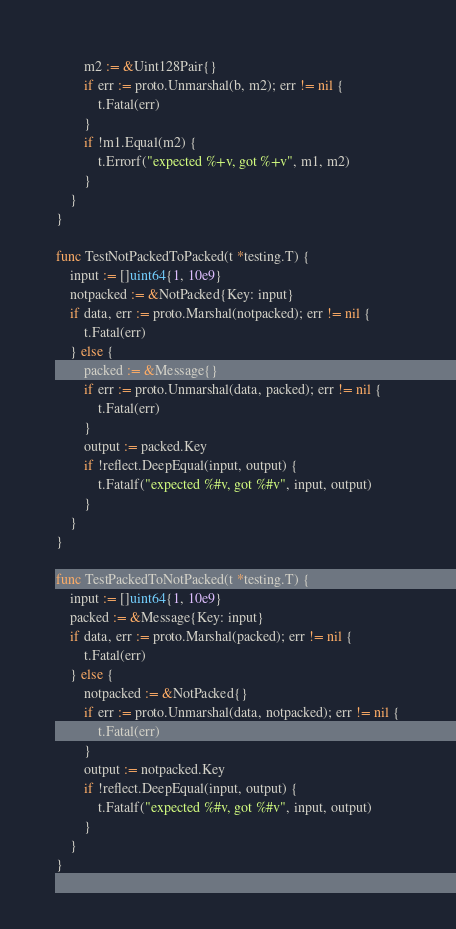Convert code to text. <code><loc_0><loc_0><loc_500><loc_500><_Go_>		m2 := &Uint128Pair{}
		if err := proto.Unmarshal(b, m2); err != nil {
			t.Fatal(err)
		}
		if !m1.Equal(m2) {
			t.Errorf("expected %+v, got %+v", m1, m2)
		}
	}
}

func TestNotPackedToPacked(t *testing.T) {
	input := []uint64{1, 10e9}
	notpacked := &NotPacked{Key: input}
	if data, err := proto.Marshal(notpacked); err != nil {
		t.Fatal(err)
	} else {
		packed := &Message{}
		if err := proto.Unmarshal(data, packed); err != nil {
			t.Fatal(err)
		}
		output := packed.Key
		if !reflect.DeepEqual(input, output) {
			t.Fatalf("expected %#v, got %#v", input, output)
		}
	}
}

func TestPackedToNotPacked(t *testing.T) {
	input := []uint64{1, 10e9}
	packed := &Message{Key: input}
	if data, err := proto.Marshal(packed); err != nil {
		t.Fatal(err)
	} else {
		notpacked := &NotPacked{}
		if err := proto.Unmarshal(data, notpacked); err != nil {
			t.Fatal(err)
		}
		output := notpacked.Key
		if !reflect.DeepEqual(input, output) {
			t.Fatalf("expected %#v, got %#v", input, output)
		}
	}
}
</code> 